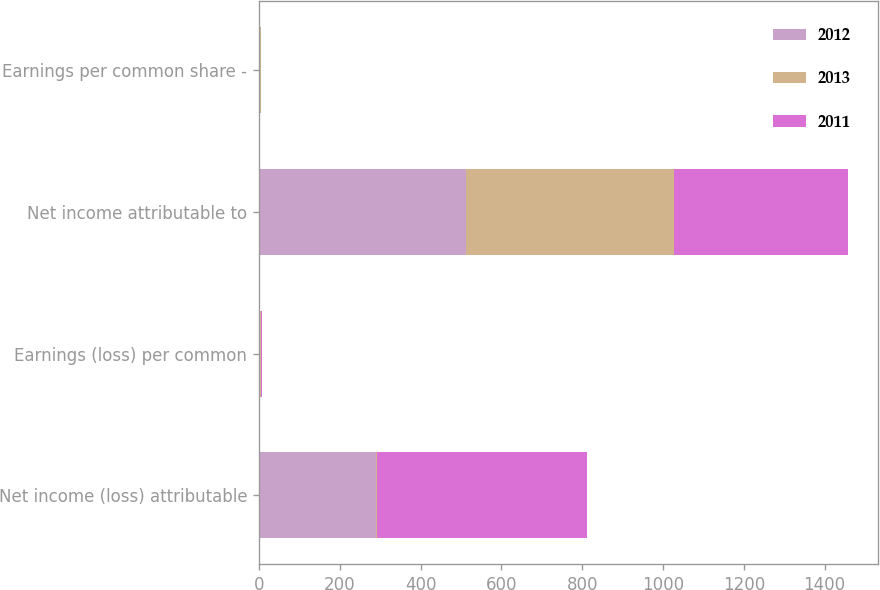Convert chart to OTSL. <chart><loc_0><loc_0><loc_500><loc_500><stacked_bar_chart><ecel><fcel>Net income (loss) attributable<fcel>Earnings (loss) per common<fcel>Net income attributable to<fcel>Earnings per common share -<nl><fcel>2012<fcel>289<fcel>1.18<fcel>512<fcel>2.1<nl><fcel>2013<fcel>4.01<fcel>4.01<fcel>516<fcel>2.13<nl><fcel>2011<fcel>519<fcel>2.15<fcel>431<fcel>1.79<nl></chart> 